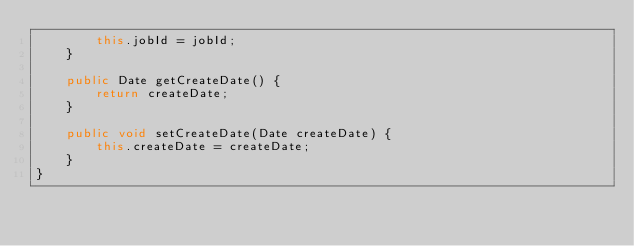<code> <loc_0><loc_0><loc_500><loc_500><_Java_>        this.jobId = jobId;
    }

    public Date getCreateDate() {
        return createDate;
    }

    public void setCreateDate(Date createDate) {
        this.createDate = createDate;
    }
}
</code> 